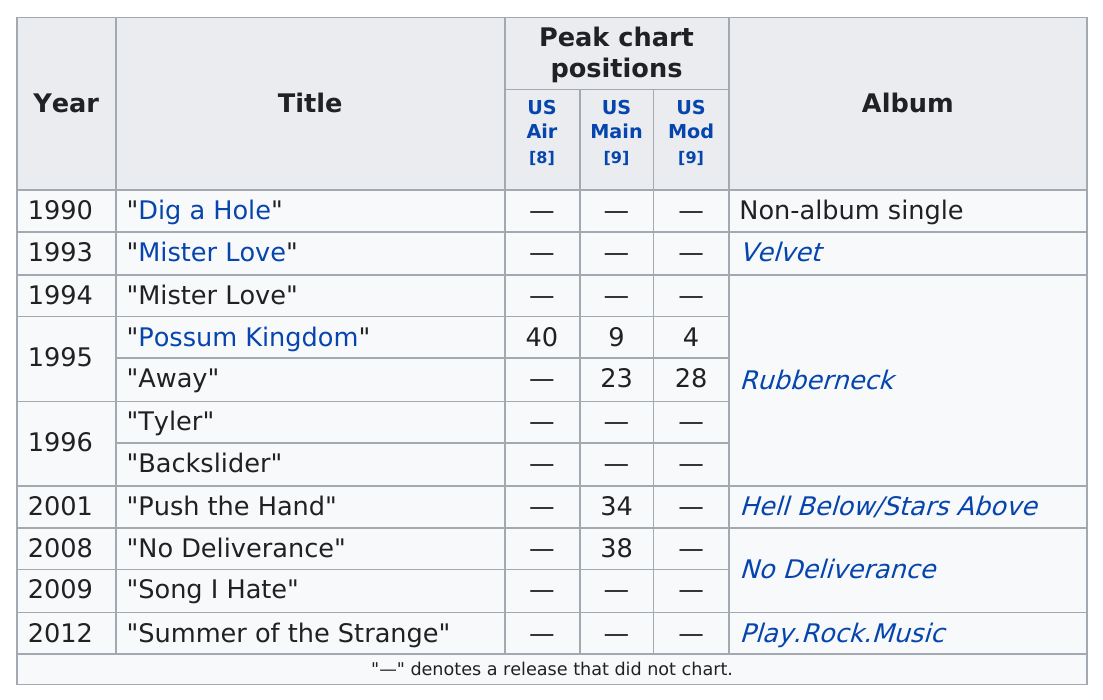Mention a couple of crucial points in this snapshot. Five albums are represented in the singles chart. Four songs have reached the US main charts. The total number of albums that were released is 5. The single "Backslider" was released before the single that was released before "Tyler..." was released. The song "Mister Love" by the Toadies appeared in the album "Velvet 